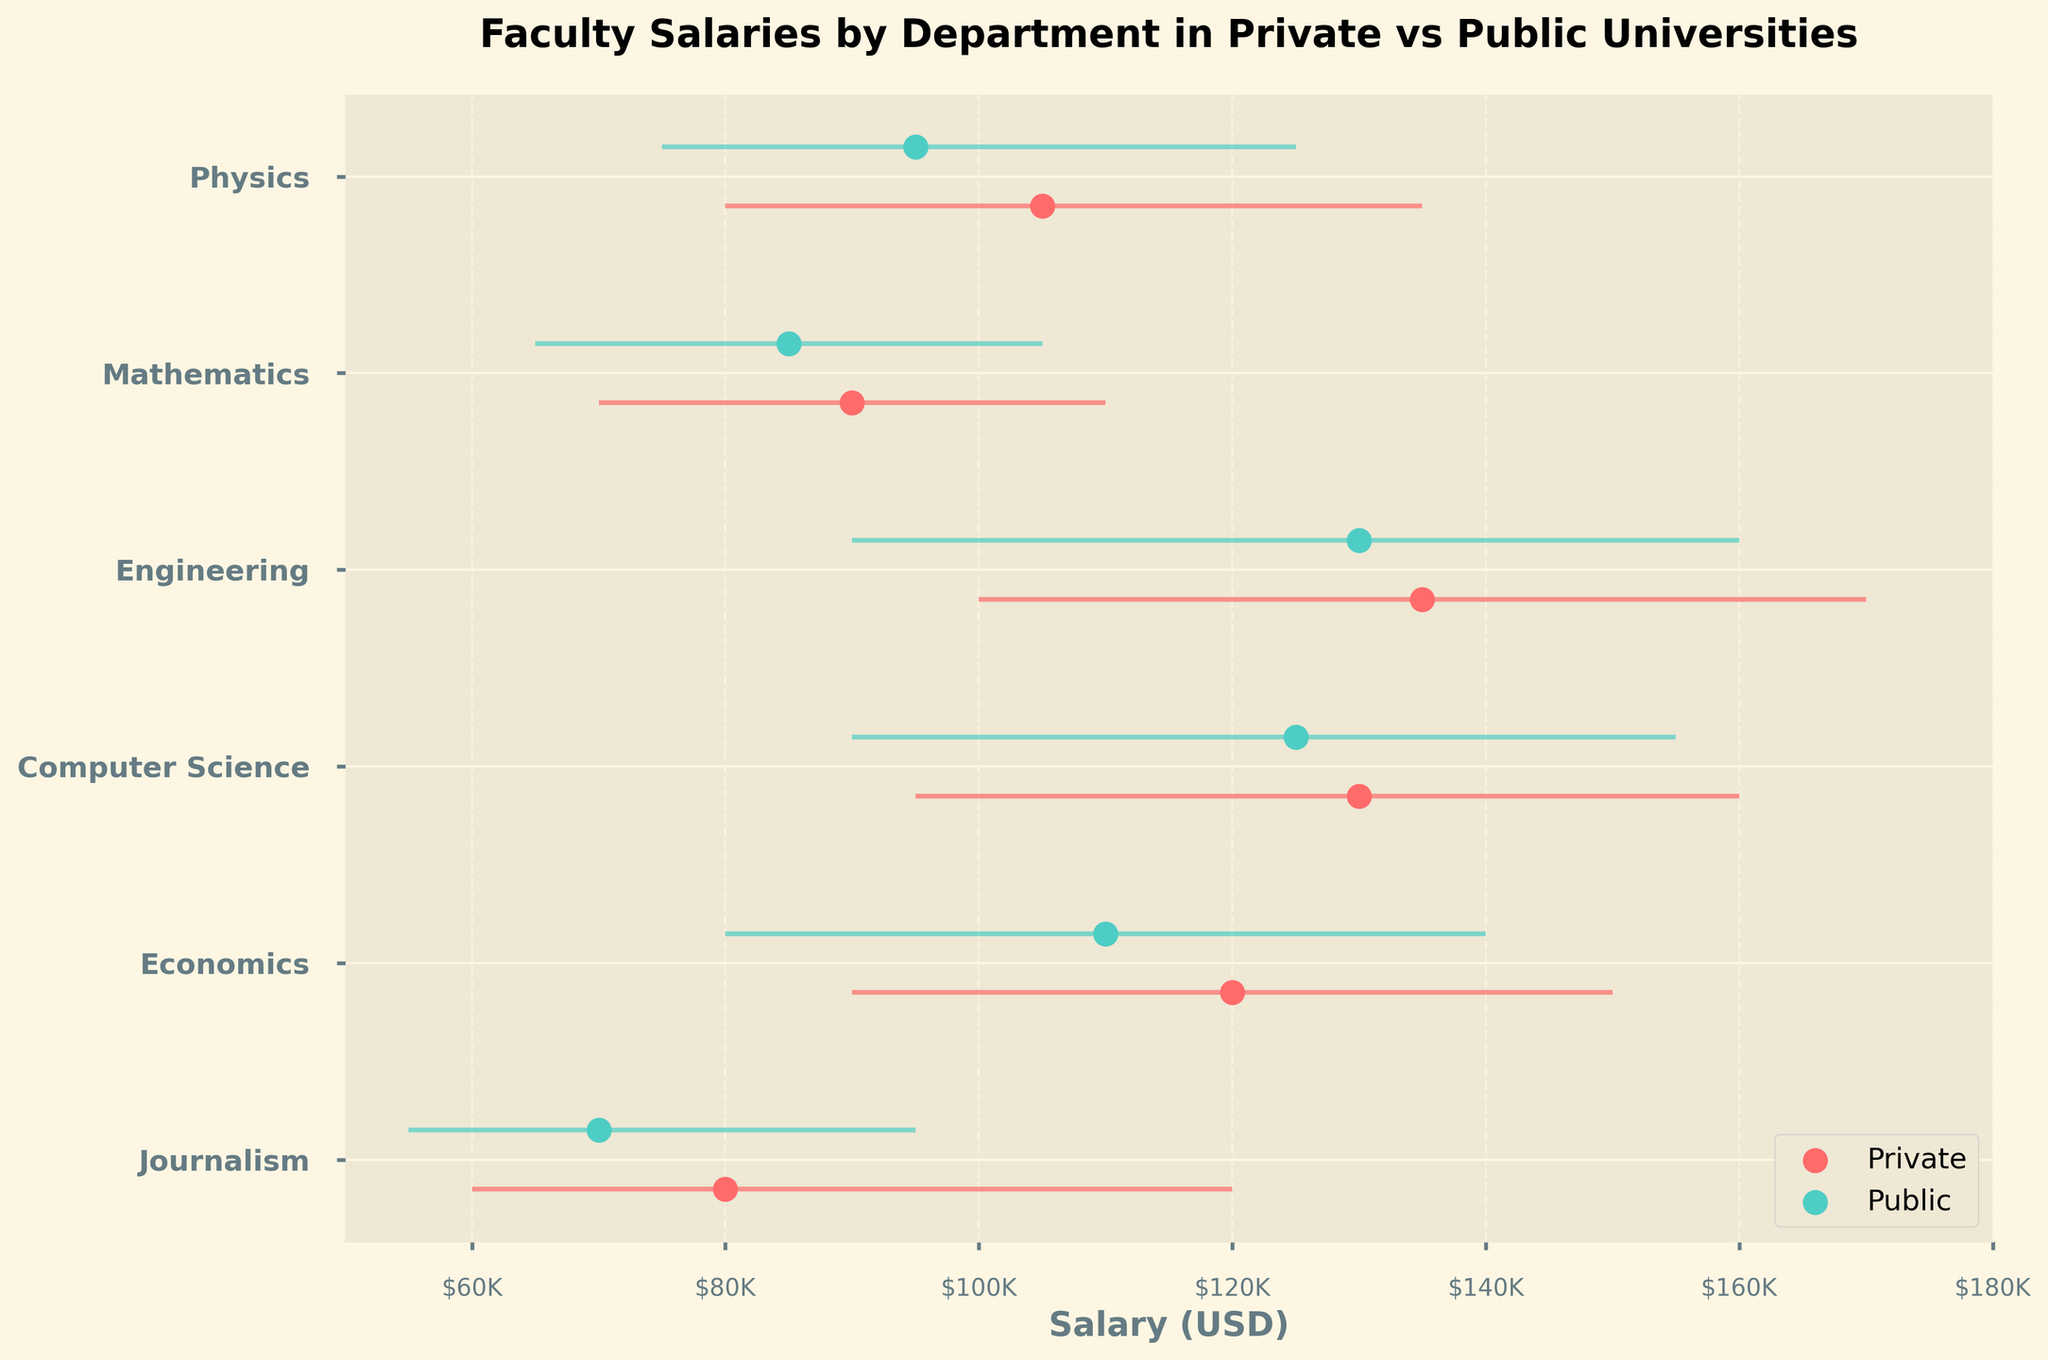What is the title of the figure? The title can be found at the top of the plot where the text usually indicates the main subject being visualized. The title here states the focus on faculty salaries by department and the distinction between private and public universities.
Answer: Faculty Salaries by Department in Private vs Public Universities What is the median salary for Journalism faculty in Public universities? Locate the dot that represents Journalism for Public universities in the plot. It is placed on the salary axis at the median value for this category. According to the data, this value should align with $70,000.
Answer: $70,000 Which department has the highest maximum salary in Private universities? Examine the horizontal lines representing salary ranges for each department under Private universities. Identify the line that extends the furthest to the right, representing the highest maximum salary. The Engineering department has a line extending to $170,000.
Answer: Engineering How does the median salary for Economics faculty in Public universities compare to that in Private universities? Compare the positions of the median salary dots for Economics under Public and Private universities. The median for Public is $110,000 and for Private is $120,000. The value for Private is higher by $10,000.
Answer: Higher by $10,000 What is the range of salaries for Computer Science faculty in Public universities? Identify the horizontal line representing the salary range for Computer Science faculty in Public universities. The line starts at the minimum salary and ends at the maximum salary. According to the data, this range is from $90,000 to $155,000.
Answer: $90,000 to $155,000 What can you infer about the overall trend of salaries in Private vs Public universities? Observe the clusters of dots and the lengths of the horizontal salary ranges. In most cases, the dots representing median salaries for Private universities are placed higher on the salary axis than those for Public universities. Additionally, the salary ranges (horizontal lines) for Private universities are generally longer and on the upper end of the scale. This indicates that faculty salaries in Private universities tend to be higher than those in Public universities overall.
Answer: Private universities generally pay higher salaries than Public universities What is the difference between the maximum salary for Mathematics faculty at Private universities and at Public universities? Compare the maximum salary points for Mathematics in both Private and Public universities. Private universities offer a maximum salary of $110,000 while Public universities offer up to $105,000. The difference is $5,000.
Answer: $5,000 Which department has the smallest salary range in Public universities and what is that range? Look at the shortest horizontal line among all departments for Public universities. The Journalism department has the smallest range, spanning from $55,000 to $95,000, which is a difference of $40,000.
Answer: Journalism with a $40,000 range For which department and university type is the median salary closest to $100,000? Locate the median salary dots closest to the $100,000 mark on the salary axis. The Physics department in Private universities has a median salary that is exactly $105,000, which is closest to $100,000.
Answer: Physics in Private universities Which department has a higher median salary in Public universities than Private universities? Compare the position of median salary dots for each department in Public versus Private universities. No department in Public universities has a higher median salary than its counterpart in Private universities.
Answer: None 